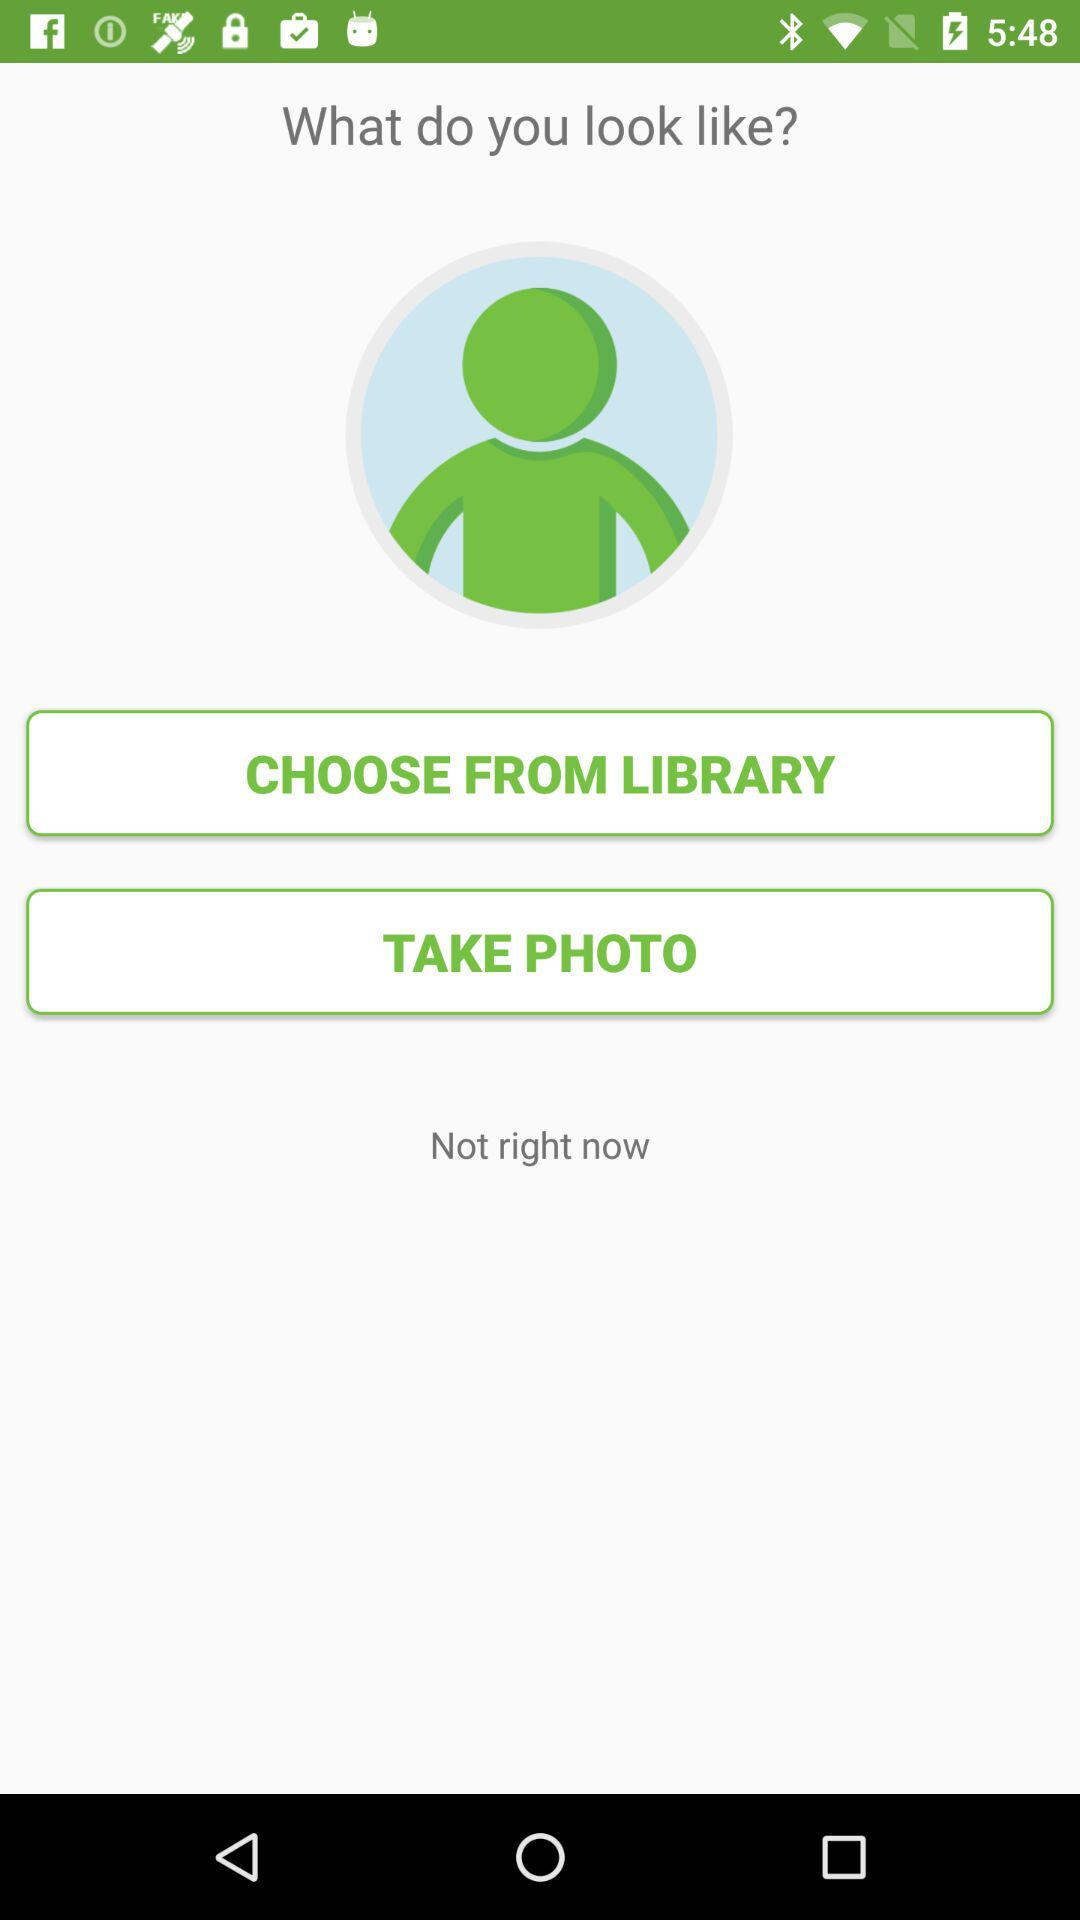From where can the user choose a photo to upload? The user can choose a photo from the library to upload. 